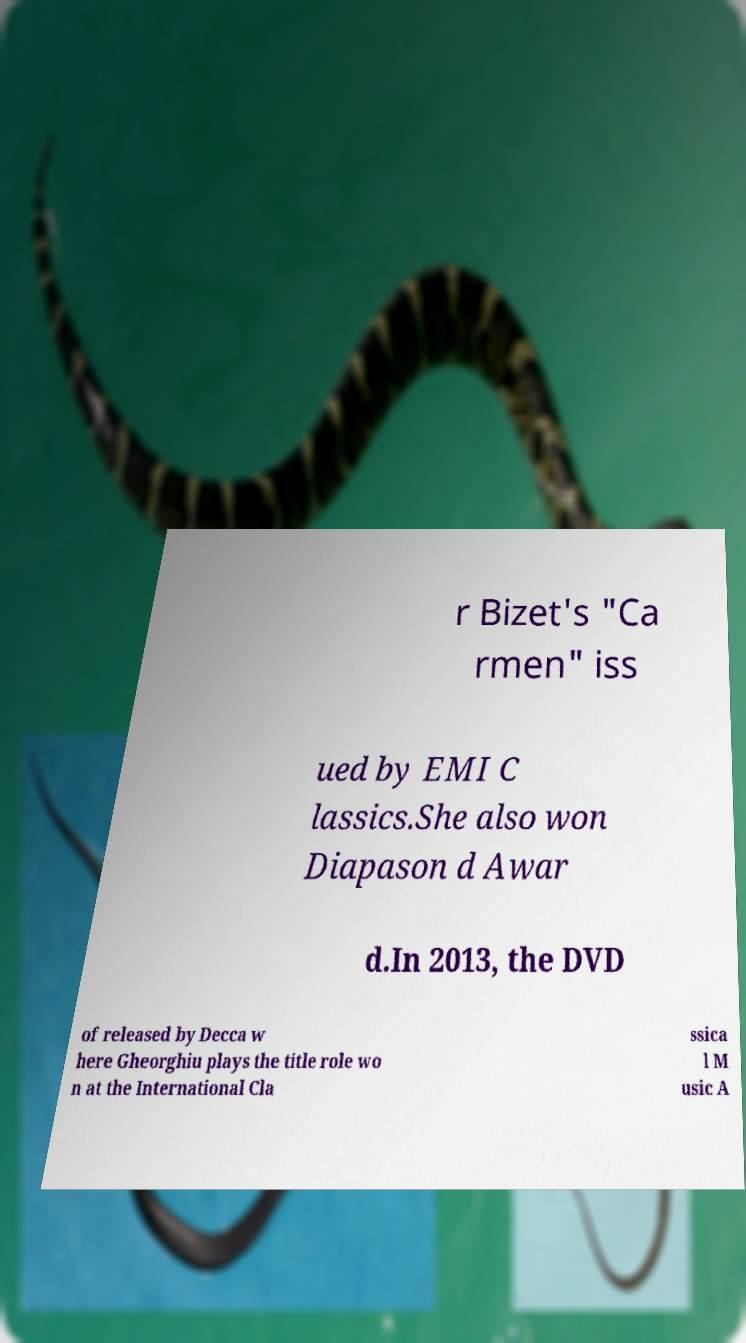There's text embedded in this image that I need extracted. Can you transcribe it verbatim? r Bizet's "Ca rmen" iss ued by EMI C lassics.She also won Diapason d Awar d.In 2013, the DVD of released by Decca w here Gheorghiu plays the title role wo n at the International Cla ssica l M usic A 